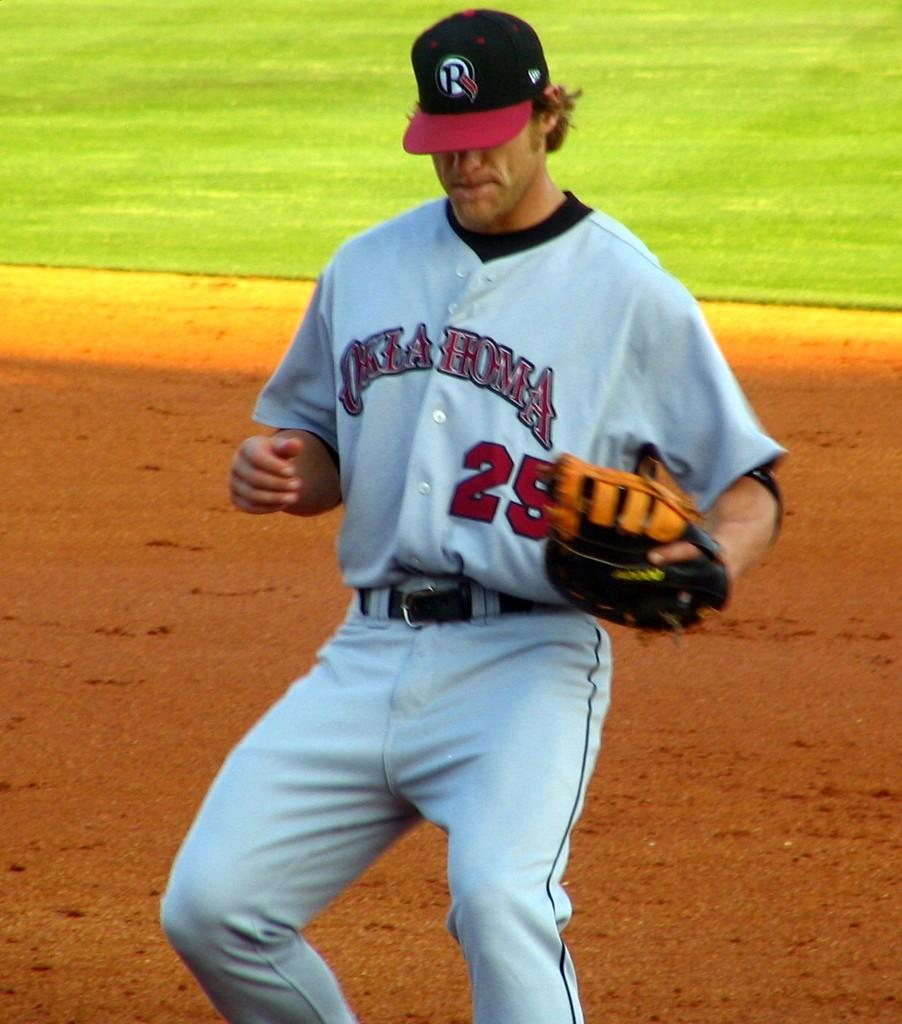<image>
Offer a succinct explanation of the picture presented. Ball player in white uniform with Oklahoma in red letters on his uniform. 